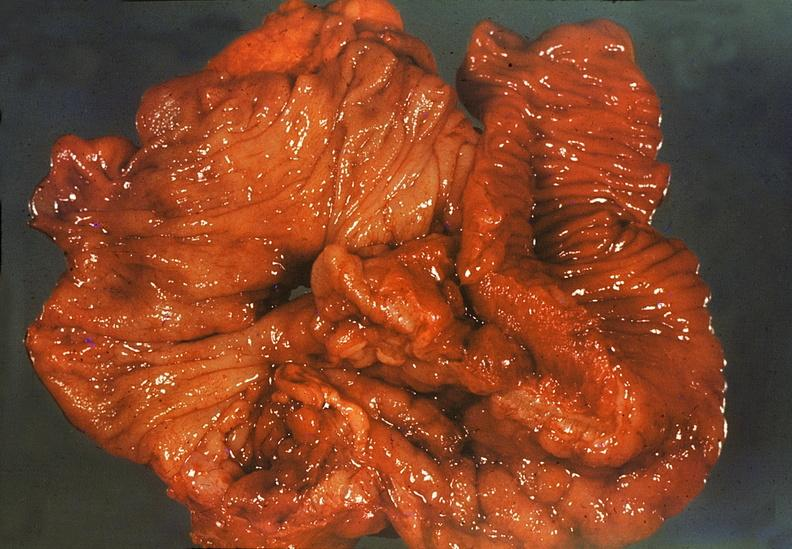does surface show ileum, regional enteritis?
Answer the question using a single word or phrase. No 